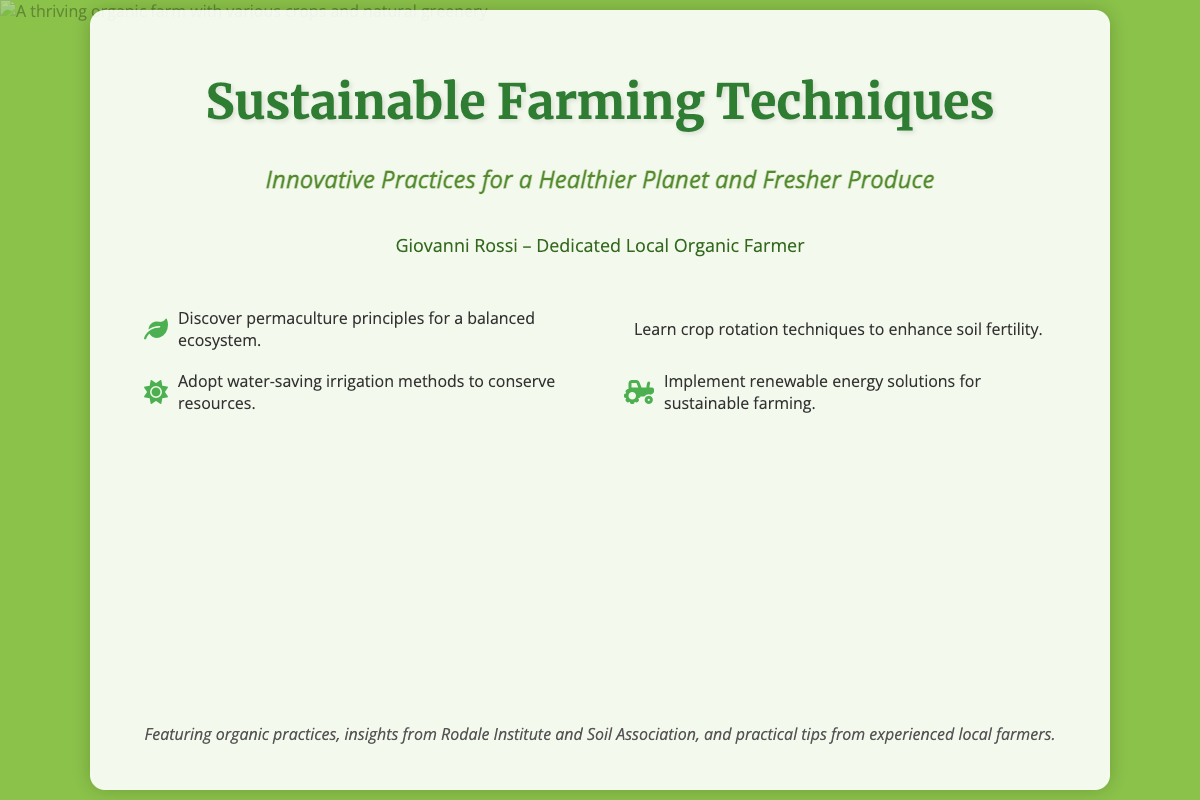What is the title of the book? The title of the book is presented prominently at the top of the cover.
Answer: Sustainable Farming Techniques Who is the author of the book? The author is listed beneath the title, indicating the person who wrote the book.
Answer: Giovanni Rossi What does the subtitle suggest about the book's content? The subtitle provides insight into what the book covers, hinting at its themes and focus.
Answer: Innovative Practices for a Healthier Planet and Fresher Produce What sustainable practice is highlighted for enhancing soil fertility? The document mentions a technique related to soil fertility as part of the sustainable practices discussed.
Answer: Crop rotation techniques Which organization is mentioned in the additional notes? The additional notes refer to a reputable organization in the field of sustainable farming, relevant to the book.
Answer: Rodale Institute How many bullet points are listed on the cover? The list of techniques features a specific number of items that summarize the book's main points.
Answer: Four What is one method suggested for saving water in farming? The text provides a specific irrigation method aimed at conserving water resources.
Answer: Water-saving irrigation methods What color represents the background of the book cover? The background color is a significant design choice, representing the natural theme of the publication.
Answer: Green 